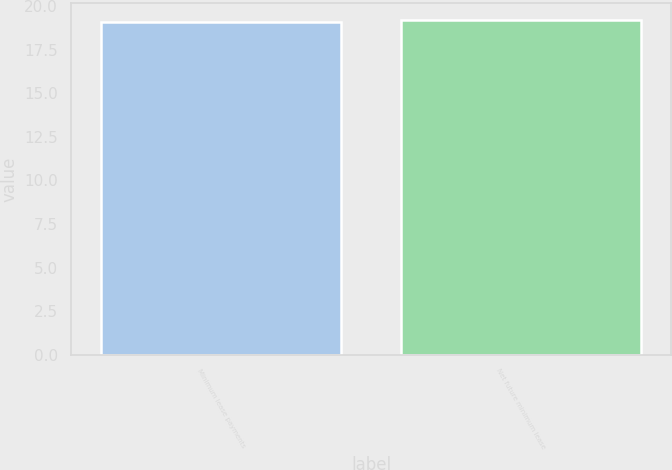<chart> <loc_0><loc_0><loc_500><loc_500><bar_chart><fcel>Minimum lease payments<fcel>Net future minimum lease<nl><fcel>19.1<fcel>19.2<nl></chart> 